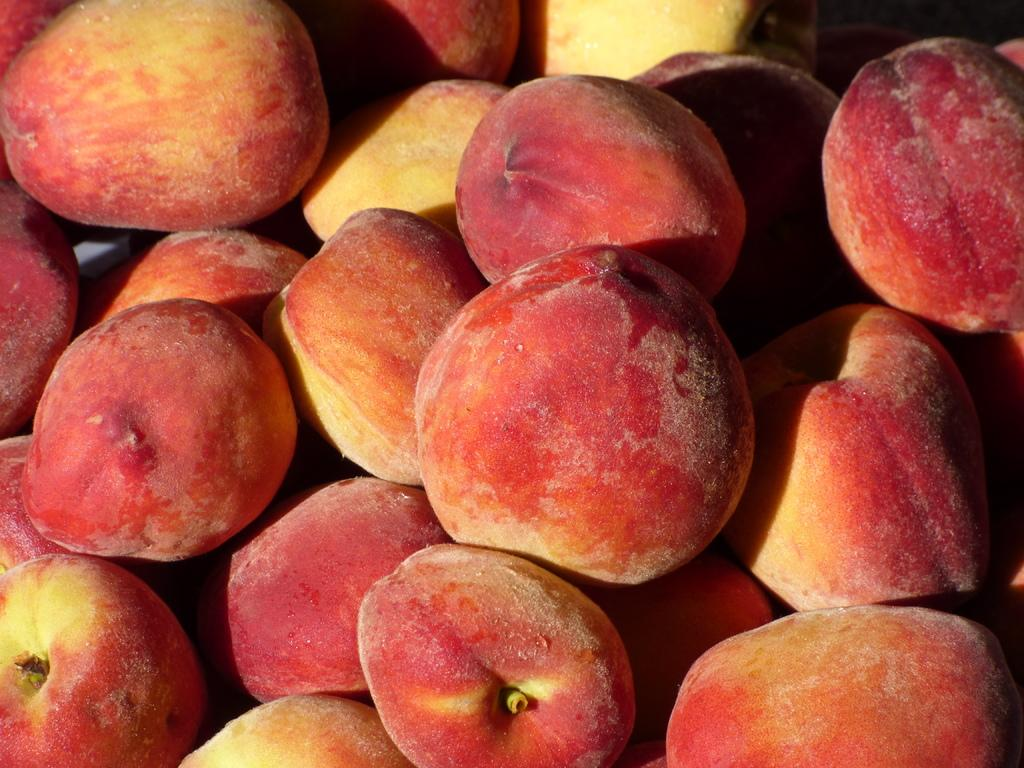What type of objects are present in the image? There is a group of fruits in the image. Can you describe the fruits in the image? Unfortunately, the facts provided do not give specific details about the fruits. How many fruits are in the group? The number of fruits in the group is not mentioned in the provided facts. What type of building can be seen in the background of the image? There is no building present in the image, as it only features a group of fruits. How does the can help in the image? There is no can present in the image, so it cannot be used for any purpose. 